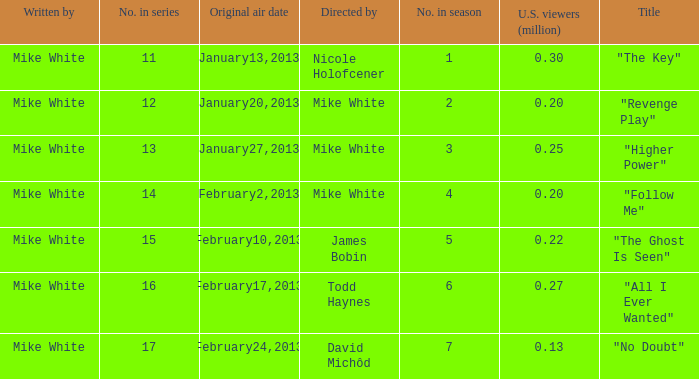How many episodes in the serie were title "the key" 1.0. Write the full table. {'header': ['Written by', 'No. in series', 'Original air date', 'Directed by', 'No. in season', 'U.S. viewers (million)', 'Title'], 'rows': [['Mike White', '11', 'January13,2013', 'Nicole Holofcener', '1', '0.30', '"The Key"'], ['Mike White', '12', 'January20,2013', 'Mike White', '2', '0.20', '"Revenge Play"'], ['Mike White', '13', 'January27,2013', 'Mike White', '3', '0.25', '"Higher Power"'], ['Mike White', '14', 'February2,2013', 'Mike White', '4', '0.20', '"Follow Me"'], ['Mike White', '15', 'February10,2013', 'James Bobin', '5', '0.22', '"The Ghost Is Seen"'], ['Mike White', '16', 'February17,2013', 'Todd Haynes', '6', '0.27', '"All I Ever Wanted"'], ['Mike White', '17', 'February24,2013', 'David Michôd', '7', '0.13', '"No Doubt"']]} 